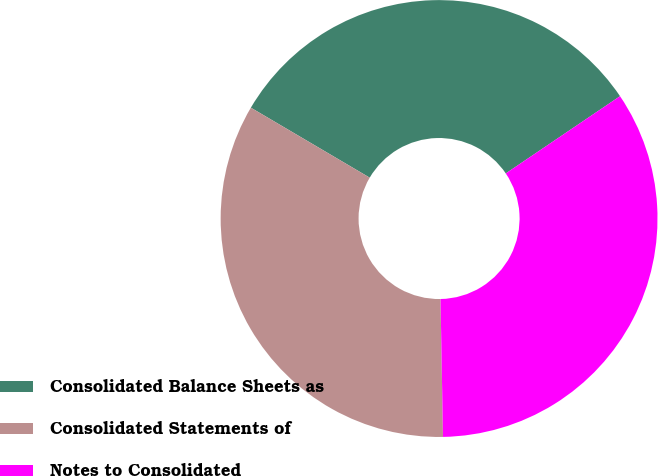Convert chart. <chart><loc_0><loc_0><loc_500><loc_500><pie_chart><fcel>Consolidated Balance Sheets as<fcel>Consolidated Statements of<fcel>Notes to Consolidated<nl><fcel>32.07%<fcel>33.76%<fcel>34.18%<nl></chart> 